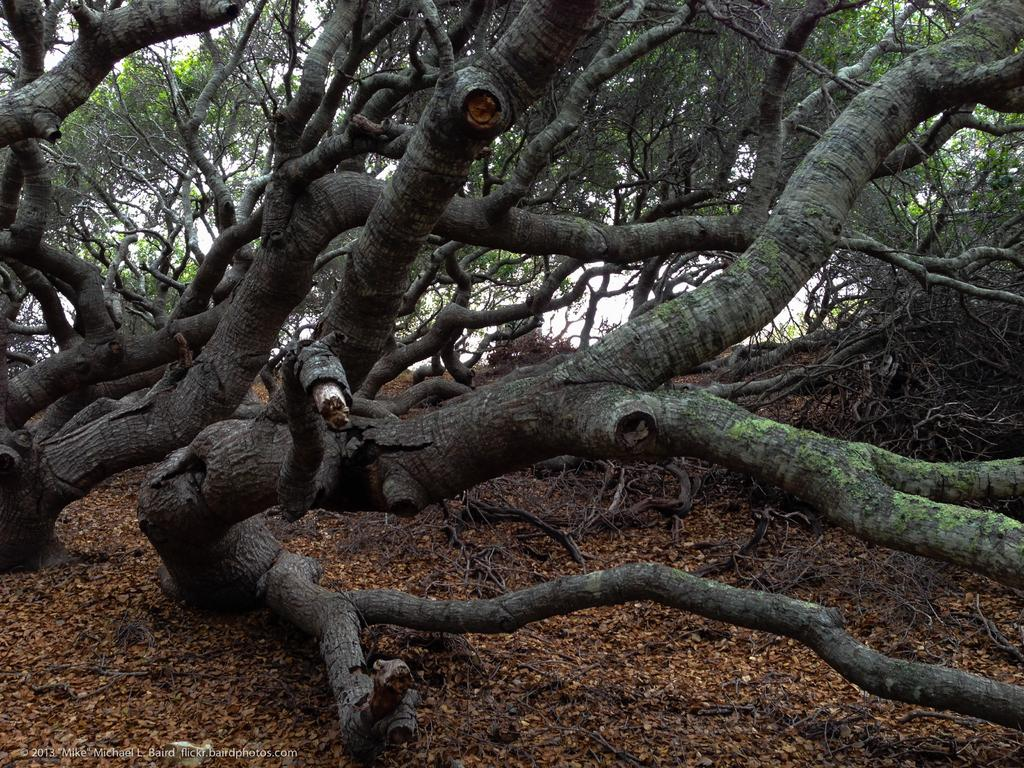What type of vegetation can be seen in the image? There are branches and trees in the image. Can you describe the branches in the image? The branches are part of the trees visible in the image. Is there any additional information about the image itself? Yes, there is a watermark on the image. What direction is the cub facing in the image? There is no cub present in the image. Can you tell me if the trees in the image are displaying any signs of anger? Trees do not have emotions, so they cannot display anger. 